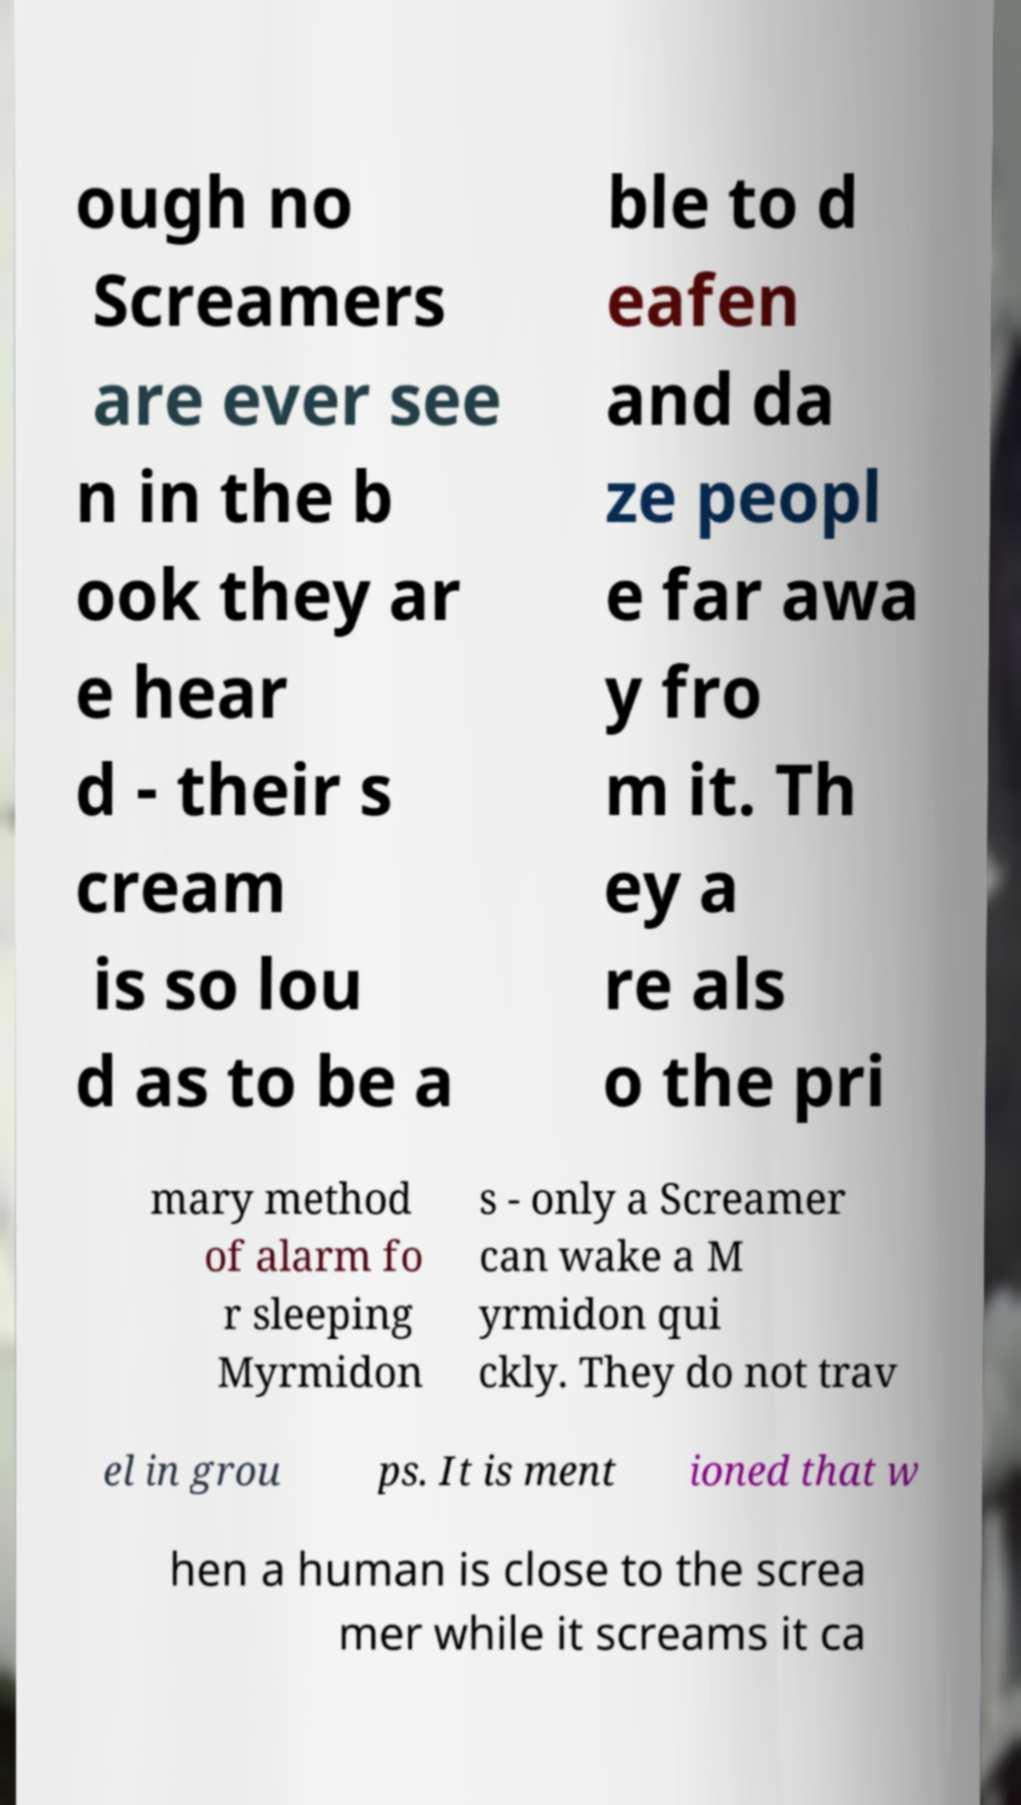For documentation purposes, I need the text within this image transcribed. Could you provide that? ough no Screamers are ever see n in the b ook they ar e hear d - their s cream is so lou d as to be a ble to d eafen and da ze peopl e far awa y fro m it. Th ey a re als o the pri mary method of alarm fo r sleeping Myrmidon s - only a Screamer can wake a M yrmidon qui ckly. They do not trav el in grou ps. It is ment ioned that w hen a human is close to the screa mer while it screams it ca 